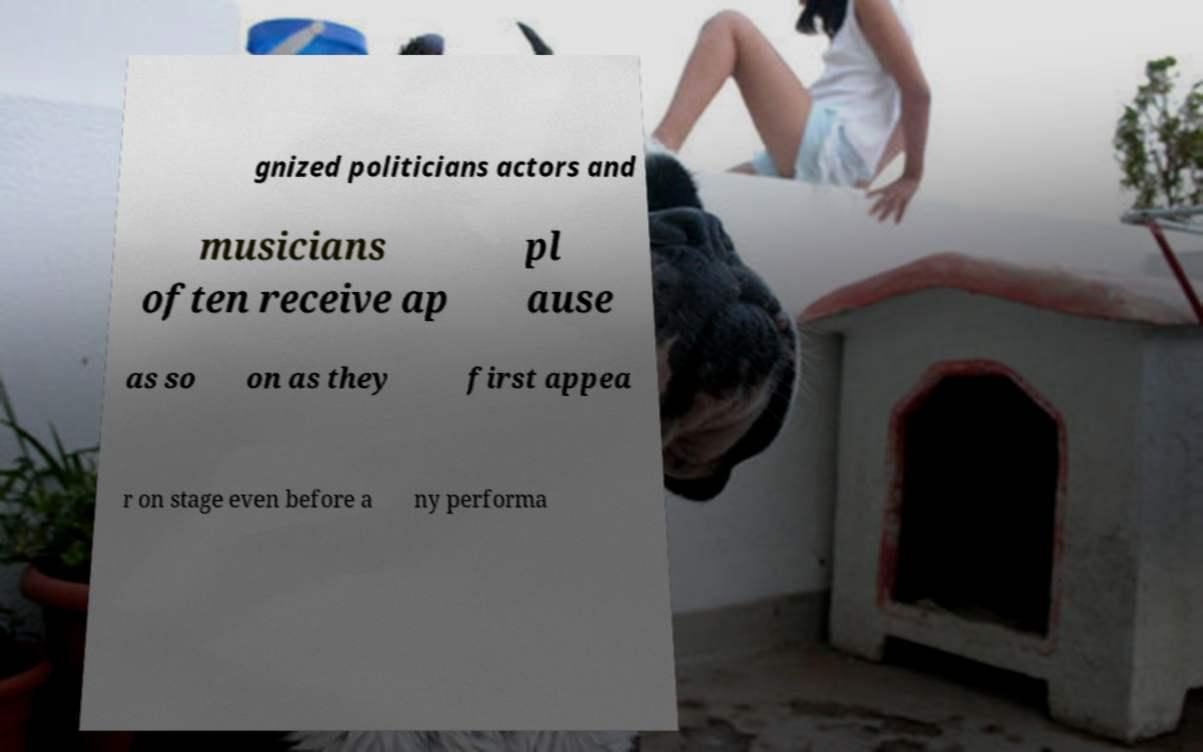For documentation purposes, I need the text within this image transcribed. Could you provide that? gnized politicians actors and musicians often receive ap pl ause as so on as they first appea r on stage even before a ny performa 